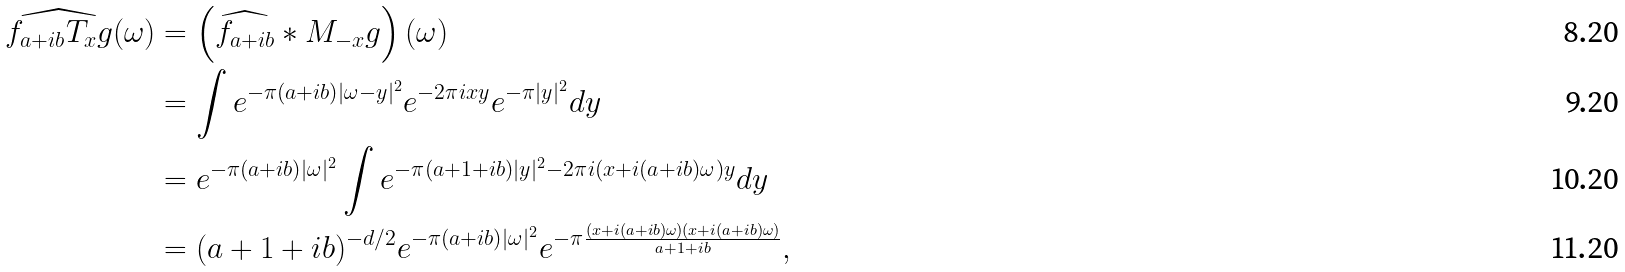<formula> <loc_0><loc_0><loc_500><loc_500>\widehat { f _ { a + i b } T _ { x } g } ( \omega ) & = \left ( \widehat { f _ { a + i b } } \ast M _ { - x } g \right ) ( \omega ) \\ & = \int e ^ { - \pi ( a + i b ) | \omega - y | ^ { 2 } } e ^ { - 2 \pi i x y } e ^ { - \pi | y | ^ { 2 } } d y \\ & = e ^ { - \pi ( a + i b ) | \omega | ^ { 2 } } \int e ^ { - \pi ( a + 1 + i b ) | y | ^ { 2 } - 2 \pi i ( x + i ( a + i b ) \omega ) y } d y \\ & = ( a + 1 + i b ) ^ { - d / 2 } e ^ { - \pi ( a + i b ) | \omega | ^ { 2 } } e ^ { - \pi \frac { ( x + i ( a + i b ) \omega ) ( x + i ( a + i b ) \omega ) } { a + 1 + i b } } ,</formula> 